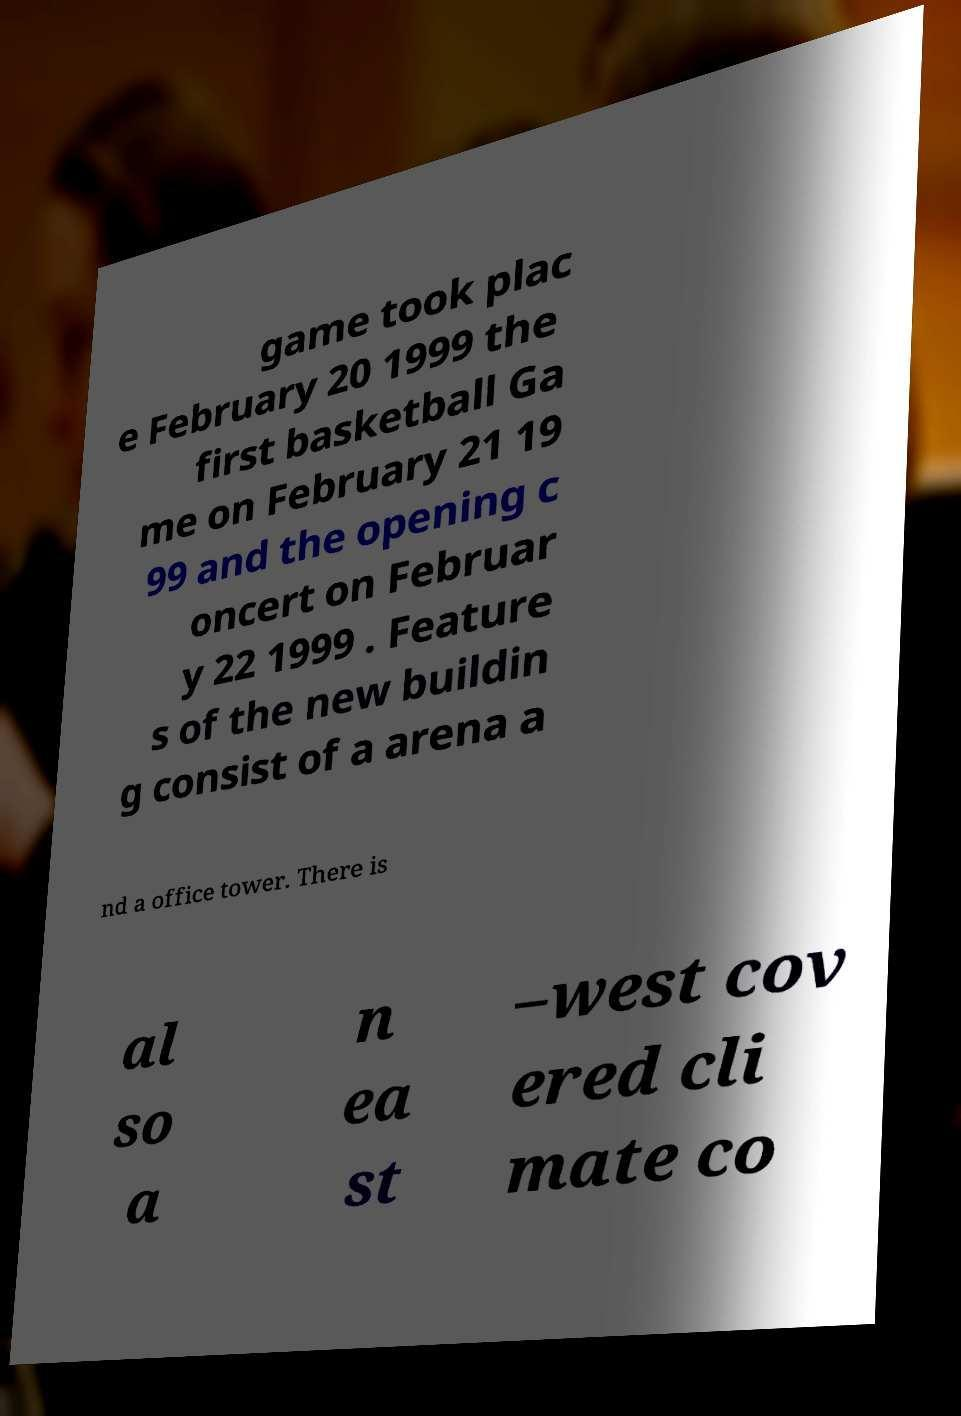Can you read and provide the text displayed in the image?This photo seems to have some interesting text. Can you extract and type it out for me? game took plac e February 20 1999 the first basketball Ga me on February 21 19 99 and the opening c oncert on Februar y 22 1999 . Feature s of the new buildin g consist of a arena a nd a office tower. There is al so a n ea st –west cov ered cli mate co 